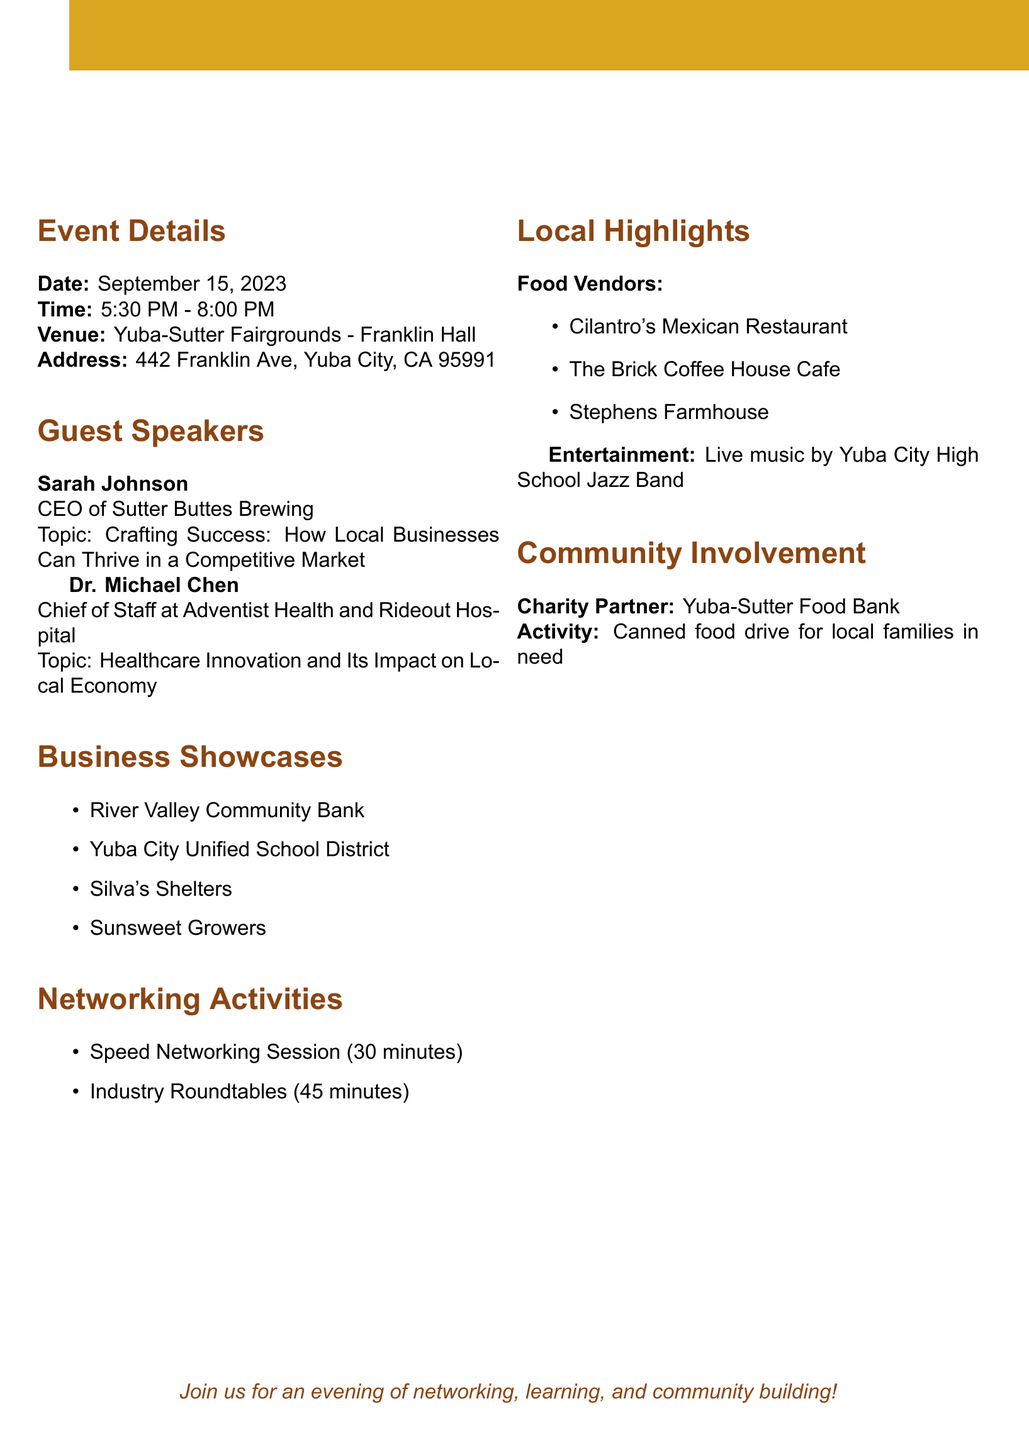What is the date of the event? The date is directly mentioned in the event details section.
Answer: September 15, 2023 Who is the CEO of Sutter Buttes Brewing? This information is provided in the guest speakers section.
Answer: Sarah Johnson What time does the networking event start? The start time is specified in the event details section.
Answer: 5:30 PM Which company focuses on small business loan programs? This is detailed in the business showcases section.
Answer: River Valley Community Bank What is the duration of the Speed Networking Session? The duration is listed in the networking activities section.
Answer: 30 minutes Who is the charity partner for the event? This information is provided in the community involvement section.
Answer: Yuba-Sutter Food Bank What is the topic of Dr. Michael Chen's speech? The topic is given in the guest speakers section.
Answer: Healthcare Innovation and Its Impact on Local Economy What type of food vendors will be present? The food vendors are listed in the local highlights section.
Answer: Cilantro's Mexican Restaurant, The Brick Coffee House Cafe, Stephens Farmhouse What activity is planned for community involvement? The activity is discussed in the community involvement section.
Answer: Canned food drive for local families in need 